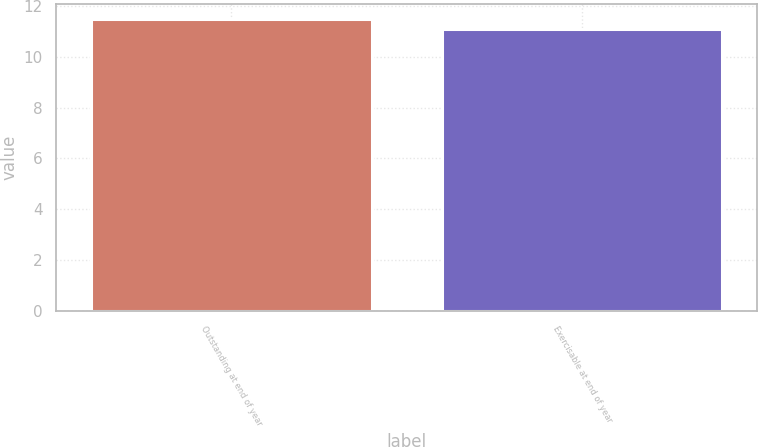Convert chart to OTSL. <chart><loc_0><loc_0><loc_500><loc_500><bar_chart><fcel>Outstanding at end of year<fcel>Exercisable at end of year<nl><fcel>11.49<fcel>11.08<nl></chart> 